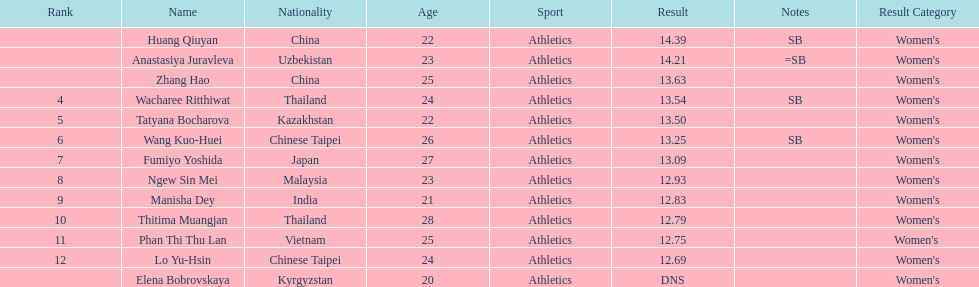What is the difference between huang qiuyan's result and fumiyo yoshida's result? 1.3. 